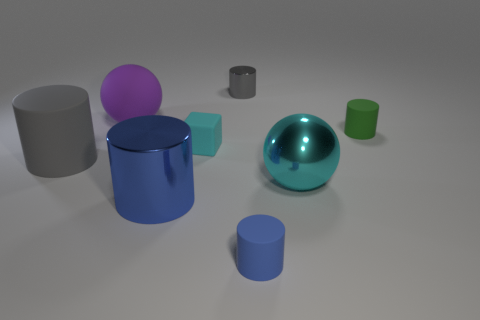How many rubber objects are both left of the tiny green matte thing and on the right side of the big purple rubber object?
Provide a short and direct response. 2. What is the material of the sphere right of the big blue metal cylinder?
Ensure brevity in your answer.  Metal. What number of tiny cylinders have the same color as the small block?
Offer a very short reply. 0. The green object that is made of the same material as the large purple ball is what size?
Provide a short and direct response. Small. How many objects are either gray objects or blue cylinders?
Your answer should be compact. 4. What is the color of the object on the left side of the big purple sphere?
Ensure brevity in your answer.  Gray. There is a blue matte thing that is the same shape as the small green object; what size is it?
Keep it short and to the point. Small. How many things are either things that are in front of the gray rubber cylinder or gray objects that are left of the small gray metallic object?
Your answer should be very brief. 4. How big is the metal thing that is in front of the big purple matte ball and to the right of the tiny cyan matte cube?
Your response must be concise. Large. There is a big purple matte thing; is it the same shape as the cyan object that is in front of the large gray matte cylinder?
Keep it short and to the point. Yes. 